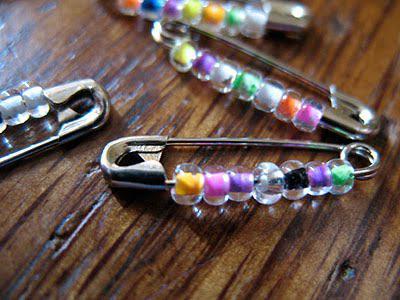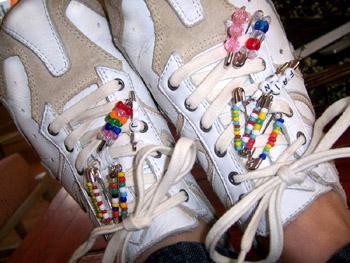The first image is the image on the left, the second image is the image on the right. Evaluate the accuracy of this statement regarding the images: "An image shows only one decorative pin with a pattern created by dangling pins strung with beads.". Is it true? Answer yes or no. No. The first image is the image on the left, the second image is the image on the right. Evaluate the accuracy of this statement regarding the images: "A bracelet made of pins is worn on a wrist in the image on the left.". Is it true? Answer yes or no. No. 